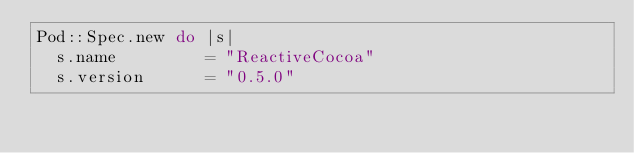Convert code to text. <code><loc_0><loc_0><loc_500><loc_500><_Ruby_>Pod::Spec.new do |s|
  s.name         = "ReactiveCocoa"
  s.version      = "0.5.0"</code> 